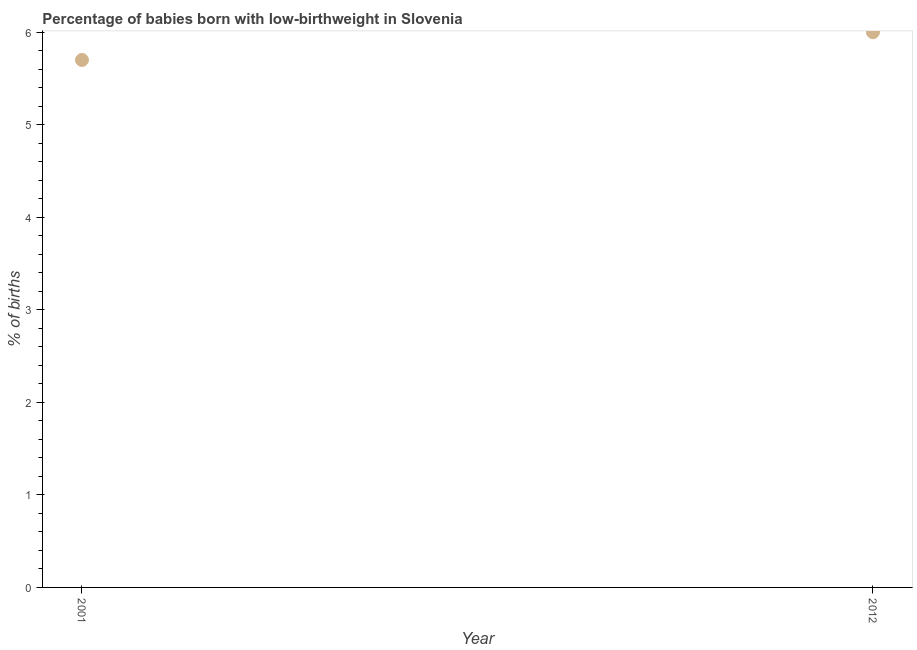What is the percentage of babies who were born with low-birthweight in 2001?
Make the answer very short. 5.7. Across all years, what is the maximum percentage of babies who were born with low-birthweight?
Provide a short and direct response. 6. Across all years, what is the minimum percentage of babies who were born with low-birthweight?
Keep it short and to the point. 5.7. In which year was the percentage of babies who were born with low-birthweight maximum?
Offer a very short reply. 2012. In which year was the percentage of babies who were born with low-birthweight minimum?
Give a very brief answer. 2001. What is the difference between the percentage of babies who were born with low-birthweight in 2001 and 2012?
Offer a very short reply. -0.3. What is the average percentage of babies who were born with low-birthweight per year?
Give a very brief answer. 5.85. What is the median percentage of babies who were born with low-birthweight?
Your response must be concise. 5.85. In how many years, is the percentage of babies who were born with low-birthweight greater than 3.8 %?
Your response must be concise. 2. Do a majority of the years between 2001 and 2012 (inclusive) have percentage of babies who were born with low-birthweight greater than 3 %?
Provide a succinct answer. Yes. What is the ratio of the percentage of babies who were born with low-birthweight in 2001 to that in 2012?
Offer a terse response. 0.95. Is the percentage of babies who were born with low-birthweight in 2001 less than that in 2012?
Give a very brief answer. Yes. In how many years, is the percentage of babies who were born with low-birthweight greater than the average percentage of babies who were born with low-birthweight taken over all years?
Provide a short and direct response. 1. How many dotlines are there?
Keep it short and to the point. 1. How many years are there in the graph?
Keep it short and to the point. 2. What is the difference between two consecutive major ticks on the Y-axis?
Offer a terse response. 1. Are the values on the major ticks of Y-axis written in scientific E-notation?
Your answer should be compact. No. What is the title of the graph?
Offer a terse response. Percentage of babies born with low-birthweight in Slovenia. What is the label or title of the Y-axis?
Give a very brief answer. % of births. What is the % of births in 2001?
Ensure brevity in your answer.  5.7. What is the difference between the % of births in 2001 and 2012?
Make the answer very short. -0.3. What is the ratio of the % of births in 2001 to that in 2012?
Your answer should be very brief. 0.95. 